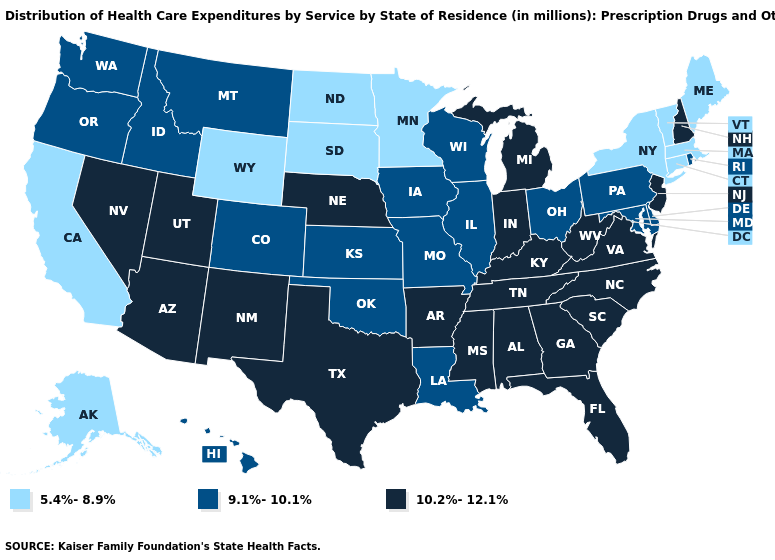Does Florida have the same value as Wyoming?
Give a very brief answer. No. Does Missouri have a higher value than Connecticut?
Quick response, please. Yes. Among the states that border Iowa , which have the highest value?
Answer briefly. Nebraska. Does Idaho have a higher value than South Dakota?
Be succinct. Yes. Among the states that border Massachusetts , does Rhode Island have the highest value?
Short answer required. No. What is the value of Alabama?
Answer briefly. 10.2%-12.1%. What is the value of Idaho?
Answer briefly. 9.1%-10.1%. What is the value of Vermont?
Give a very brief answer. 5.4%-8.9%. Does Indiana have the highest value in the MidWest?
Be succinct. Yes. Does Wisconsin have a lower value than Nebraska?
Be succinct. Yes. What is the lowest value in the USA?
Concise answer only. 5.4%-8.9%. Does the first symbol in the legend represent the smallest category?
Write a very short answer. Yes. Does Missouri have a higher value than Rhode Island?
Give a very brief answer. No. What is the value of Nevada?
Answer briefly. 10.2%-12.1%. 